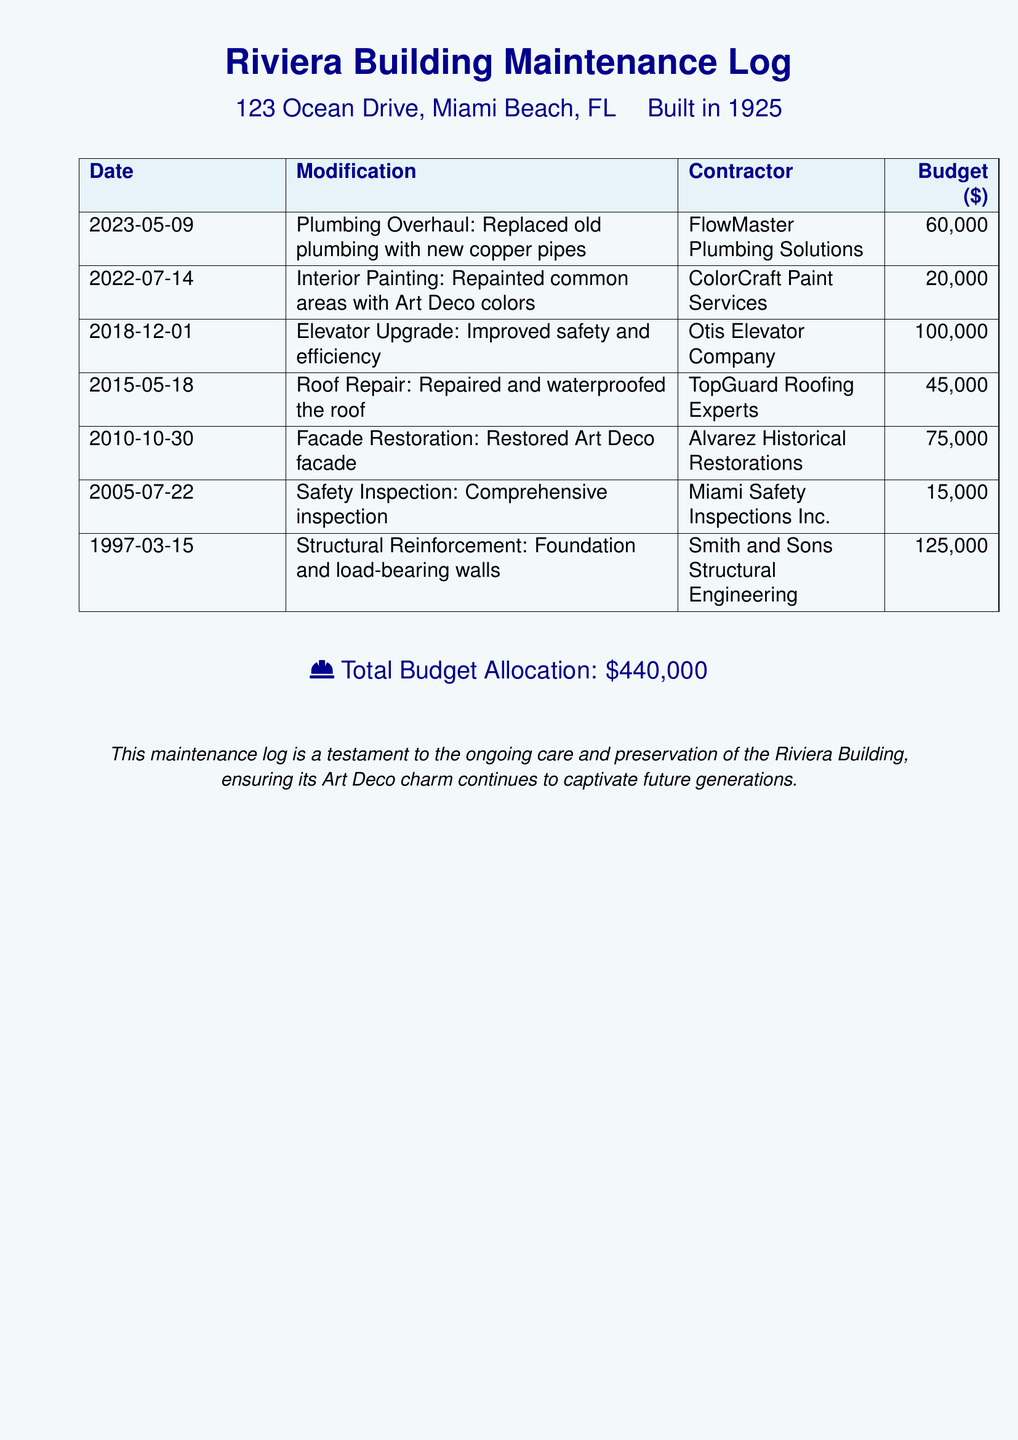What date was the plumbing overhaul completed? The date for the plumbing overhaul is listed under the Date column for that specific entry.
Answer: 2023-05-09 Which contractor performed the facade restoration? The contractor responsible for the facade restoration can be found in the corresponding entry in the document.
Answer: Alvarez Historical Restorations How much was the budget for the elevator upgrade? The budget for the elevator upgrade is provided in the specified row for that modification.
Answer: 100,000 What was the total budget allocation? The total budget allocation is summarized at the end of the document, indicating the overall expenditure for maintenance.
Answer: 440,000 How many years separate the structural reinforcement and the plumbing overhaul? Evaluating the dates of both entries reveals the number of years between them.
Answer: 26 What type of modification was made on July 14, 2022? The modification on that date is categorized specifically under the type listed next to it.
Answer: Interior Painting Which safety inspection company conducted the inspection in 2005? The document specifies the company responsible for the safety inspection in the corresponding entry.
Answer: Miami Safety Inspections Inc Which modification has the highest budget allocation? The entry with the highest budget allocation can be identified by comparing the budget numbers in the table.
Answer: Structural Reinforcement What year was the roof repair done? The year for the roof repair can be found in its respective entry within the log.
Answer: 2015 